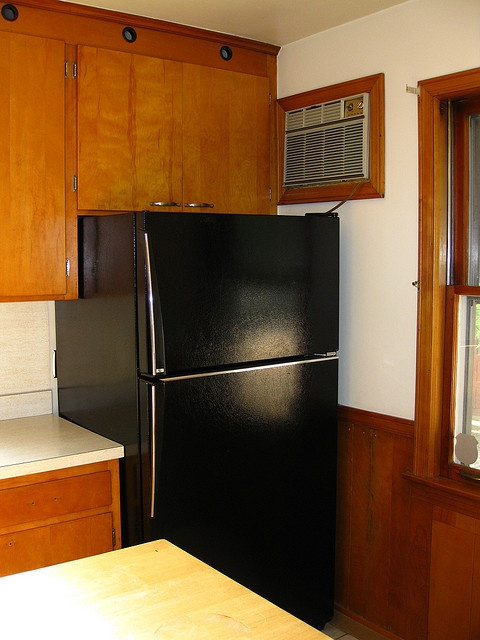Describe the objects in this image and their specific colors. I can see a refrigerator in maroon, black, and gray tones in this image. 